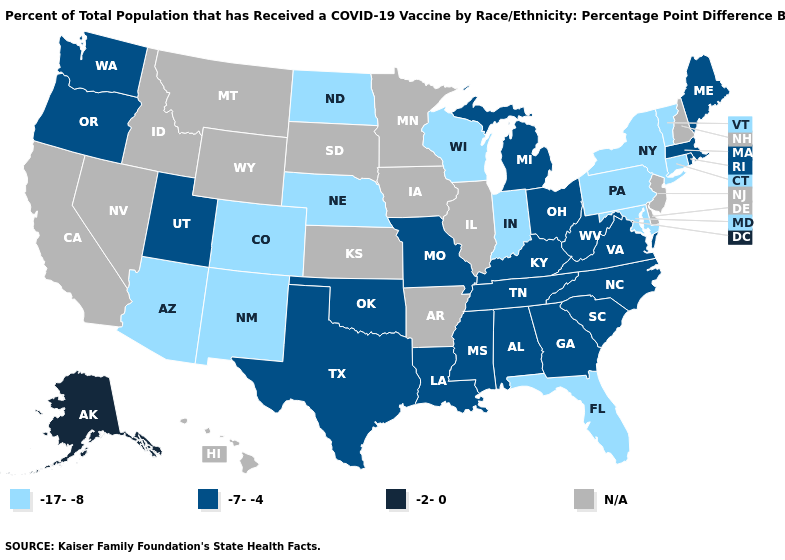Name the states that have a value in the range -7--4?
Concise answer only. Alabama, Georgia, Kentucky, Louisiana, Maine, Massachusetts, Michigan, Mississippi, Missouri, North Carolina, Ohio, Oklahoma, Oregon, Rhode Island, South Carolina, Tennessee, Texas, Utah, Virginia, Washington, West Virginia. Does Vermont have the lowest value in the USA?
Concise answer only. Yes. What is the value of Wyoming?
Answer briefly. N/A. Name the states that have a value in the range N/A?
Short answer required. Arkansas, California, Delaware, Hawaii, Idaho, Illinois, Iowa, Kansas, Minnesota, Montana, Nevada, New Hampshire, New Jersey, South Dakota, Wyoming. Name the states that have a value in the range -7--4?
Concise answer only. Alabama, Georgia, Kentucky, Louisiana, Maine, Massachusetts, Michigan, Mississippi, Missouri, North Carolina, Ohio, Oklahoma, Oregon, Rhode Island, South Carolina, Tennessee, Texas, Utah, Virginia, Washington, West Virginia. Does Massachusetts have the highest value in the USA?
Quick response, please. No. What is the value of South Carolina?
Answer briefly. -7--4. What is the highest value in the MidWest ?
Give a very brief answer. -7--4. What is the value of Nevada?
Short answer required. N/A. What is the highest value in the USA?
Be succinct. -2-0. Name the states that have a value in the range N/A?
Keep it brief. Arkansas, California, Delaware, Hawaii, Idaho, Illinois, Iowa, Kansas, Minnesota, Montana, Nevada, New Hampshire, New Jersey, South Dakota, Wyoming. Which states hav the highest value in the South?
Give a very brief answer. Alabama, Georgia, Kentucky, Louisiana, Mississippi, North Carolina, Oklahoma, South Carolina, Tennessee, Texas, Virginia, West Virginia. Does Ohio have the highest value in the USA?
Short answer required. No. Which states have the lowest value in the USA?
Short answer required. Arizona, Colorado, Connecticut, Florida, Indiana, Maryland, Nebraska, New Mexico, New York, North Dakota, Pennsylvania, Vermont, Wisconsin. 